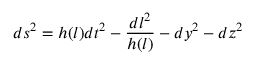Convert formula to latex. <formula><loc_0><loc_0><loc_500><loc_500>d s ^ { 2 } = h ( l ) d t ^ { 2 } - \frac { d l ^ { 2 } } { h ( l ) } - d y ^ { 2 } - d z ^ { 2 }</formula> 